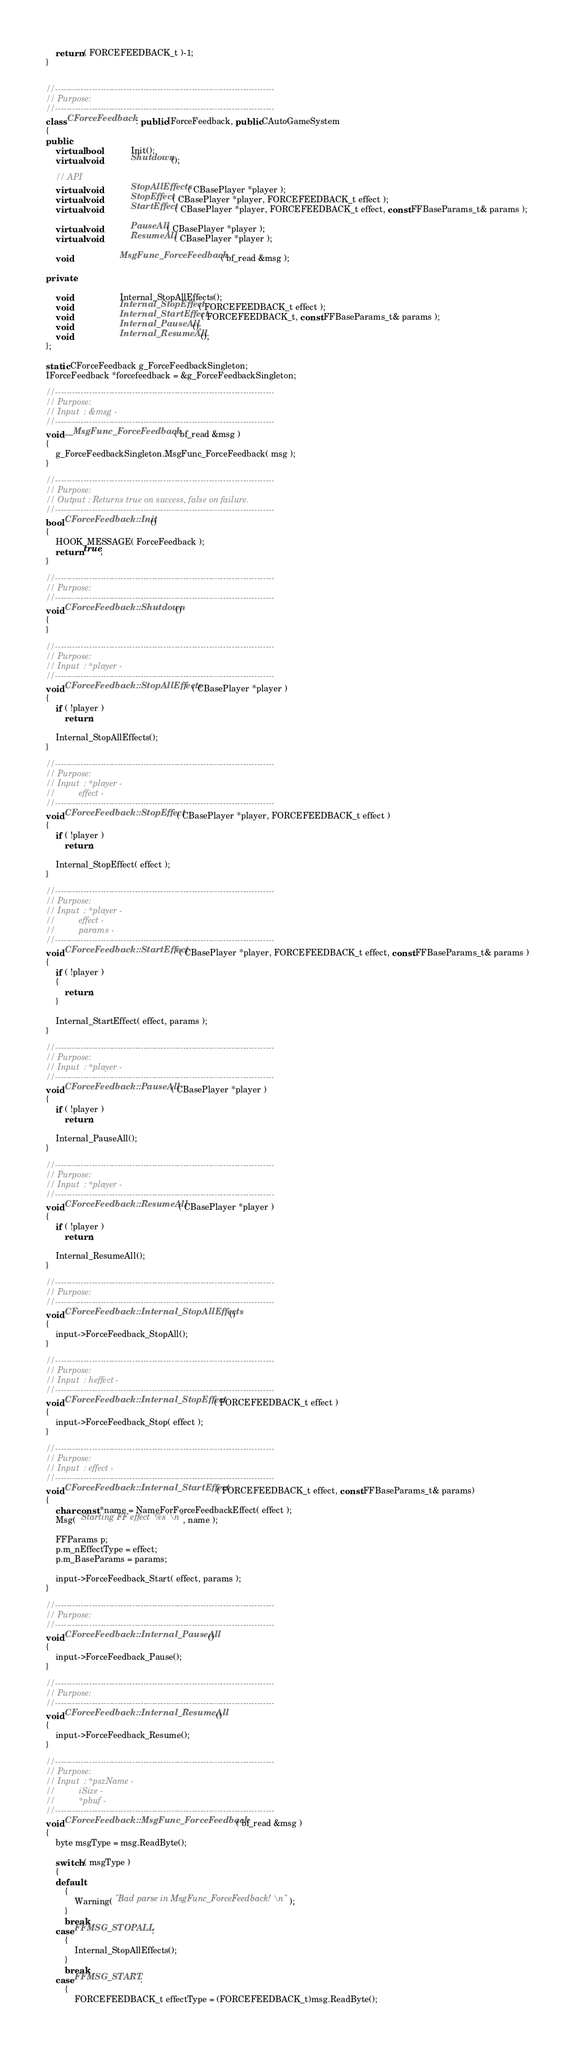Convert code to text. <code><loc_0><loc_0><loc_500><loc_500><_C++_>
	return ( FORCEFEEDBACK_t )-1;
}


//-----------------------------------------------------------------------------
// Purpose: 
//-----------------------------------------------------------------------------
class CForceFeedback : public IForceFeedback, public CAutoGameSystem
{
public:
	virtual bool			Init();
	virtual void			Shutdown();

	// API
	virtual void			StopAllEffects( CBasePlayer *player );
	virtual void			StopEffect( CBasePlayer *player, FORCEFEEDBACK_t effect );
	virtual void			StartEffect( CBasePlayer *player, FORCEFEEDBACK_t effect, const FFBaseParams_t& params );

	virtual void			PauseAll( CBasePlayer *player );
	virtual void			ResumeAll( CBasePlayer *player );

	void					MsgFunc_ForceFeedback( bf_read &msg );

private:

	void					Internal_StopAllEffects();
	void					Internal_StopEffect( FORCEFEEDBACK_t effect );
	void					Internal_StartEffect( FORCEFEEDBACK_t, const FFBaseParams_t& params );
	void					Internal_PauseAll();
	void					Internal_ResumeAll();
};

static CForceFeedback g_ForceFeedbackSingleton;
IForceFeedback *forcefeedback = &g_ForceFeedbackSingleton;

//-----------------------------------------------------------------------------
// Purpose: 
// Input  : &msg - 
//-----------------------------------------------------------------------------
void __MsgFunc_ForceFeedback( bf_read &msg )
{
	g_ForceFeedbackSingleton.MsgFunc_ForceFeedback( msg );
}

//-----------------------------------------------------------------------------
// Purpose: 
// Output : Returns true on success, false on failure.
//-----------------------------------------------------------------------------
bool CForceFeedback::Init()
{
	HOOK_MESSAGE( ForceFeedback );
	return true;
}

//-----------------------------------------------------------------------------
// Purpose: 
//-----------------------------------------------------------------------------
void CForceFeedback::Shutdown()
{
}

//-----------------------------------------------------------------------------
// Purpose: 
// Input  : *player - 
//-----------------------------------------------------------------------------
void CForceFeedback::StopAllEffects( CBasePlayer *player )
{
	if ( !player )
		return;

	Internal_StopAllEffects();
}

//-----------------------------------------------------------------------------
// Purpose: 
// Input  : *player - 
//			effect - 
//-----------------------------------------------------------------------------
void CForceFeedback::StopEffect( CBasePlayer *player, FORCEFEEDBACK_t effect )
{
	if ( !player )
		return;

	Internal_StopEffect( effect );
}

//-----------------------------------------------------------------------------
// Purpose: 
// Input  : *player - 
//			effect - 
//			params - 
//-----------------------------------------------------------------------------
void CForceFeedback::StartEffect( CBasePlayer *player, FORCEFEEDBACK_t effect, const FFBaseParams_t& params )
{
	if ( !player )
	{
		return;
	}

	Internal_StartEffect( effect, params );
}

//-----------------------------------------------------------------------------
// Purpose: 
// Input  : *player - 
//-----------------------------------------------------------------------------
void CForceFeedback::PauseAll( CBasePlayer *player )
{
	if ( !player )
		return;

	Internal_PauseAll();
}

//-----------------------------------------------------------------------------
// Purpose: 
// Input  : *player - 
//-----------------------------------------------------------------------------
void CForceFeedback::ResumeAll( CBasePlayer *player )
{
	if ( !player )
		return;

	Internal_ResumeAll();
}

//-----------------------------------------------------------------------------
// Purpose: 
//-----------------------------------------------------------------------------
void CForceFeedback::Internal_StopAllEffects()
{
	input->ForceFeedback_StopAll();
}

//-----------------------------------------------------------------------------
// Purpose: 
// Input  : heffect - 
//-----------------------------------------------------------------------------
void CForceFeedback::Internal_StopEffect( FORCEFEEDBACK_t effect )
{
	input->ForceFeedback_Stop( effect );
}

//-----------------------------------------------------------------------------
// Purpose: 
// Input  : effect - 
//-----------------------------------------------------------------------------
void CForceFeedback::Internal_StartEffect( FORCEFEEDBACK_t effect, const FFBaseParams_t& params)
{
	char const *name = NameForForceFeedbackEffect( effect );
	Msg( "Starting FF effect '%s'\n", name );

	FFParams p;
	p.m_nEffectType = effect;
	p.m_BaseParams = params;

	input->ForceFeedback_Start( effect, params );
}

//-----------------------------------------------------------------------------
// Purpose: 
//-----------------------------------------------------------------------------
void CForceFeedback::Internal_PauseAll()
{
	input->ForceFeedback_Pause();
}

//-----------------------------------------------------------------------------
// Purpose: 
//-----------------------------------------------------------------------------
void CForceFeedback::Internal_ResumeAll()
{
	input->ForceFeedback_Resume();
}

//-----------------------------------------------------------------------------
// Purpose: 
// Input  : *pszName - 
//			iSize - 
//			*pbuf - 
//-----------------------------------------------------------------------------
void CForceFeedback::MsgFunc_ForceFeedback( bf_read &msg )
{
	byte msgType = msg.ReadByte();

	switch ( msgType )
	{
	default:
		{
			Warning( "Bad parse in MsgFunc_ForceFeedback!\n" );
		}
		break;
	case FFMSG_STOPALL:
		{
			Internal_StopAllEffects();
		}
		break;
	case FFMSG_START:
		{
			FORCEFEEDBACK_t effectType = (FORCEFEEDBACK_t)msg.ReadByte();
</code> 